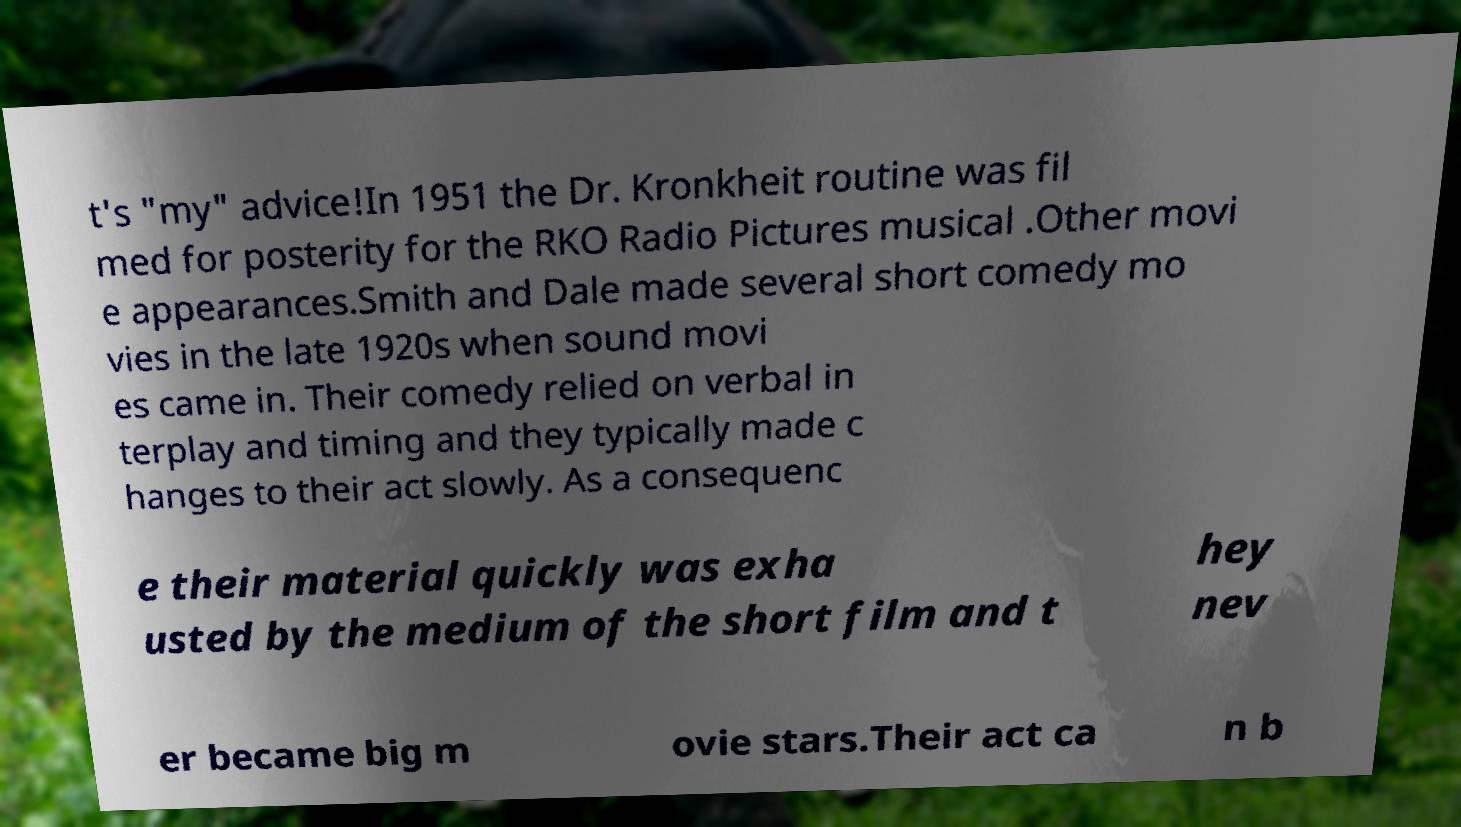Please read and relay the text visible in this image. What does it say? t's "my" advice!In 1951 the Dr. Kronkheit routine was fil med for posterity for the RKO Radio Pictures musical .Other movi e appearances.Smith and Dale made several short comedy mo vies in the late 1920s when sound movi es came in. Their comedy relied on verbal in terplay and timing and they typically made c hanges to their act slowly. As a consequenc e their material quickly was exha usted by the medium of the short film and t hey nev er became big m ovie stars.Their act ca n b 